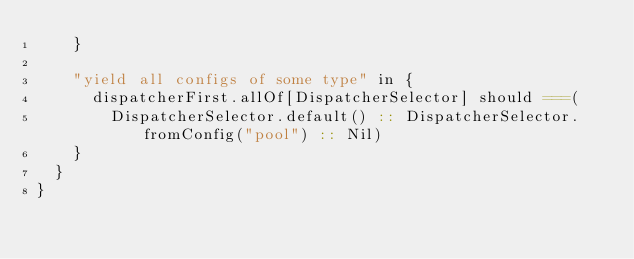<code> <loc_0><loc_0><loc_500><loc_500><_Scala_>    }

    "yield all configs of some type" in {
      dispatcherFirst.allOf[DispatcherSelector] should ===(
        DispatcherSelector.default() :: DispatcherSelector.fromConfig("pool") :: Nil)
    }
  }
}
</code> 